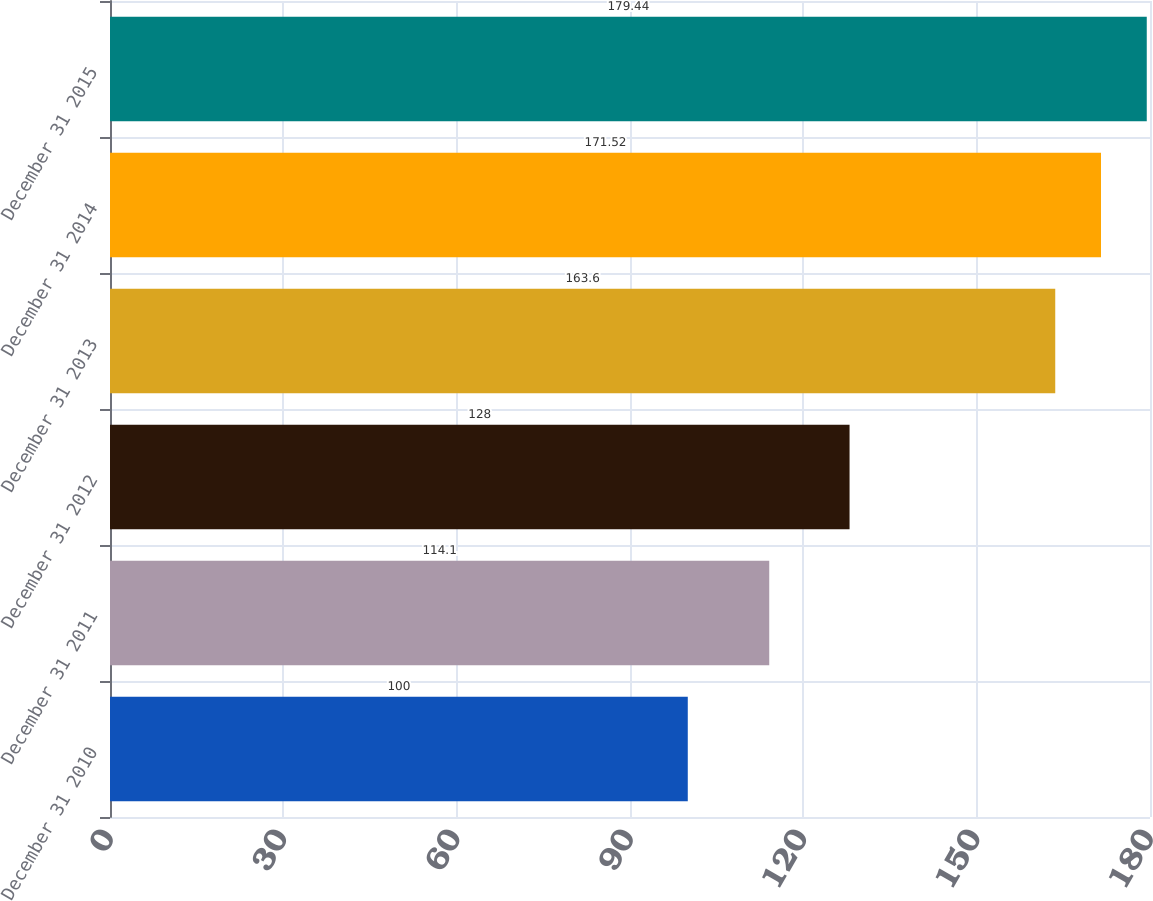Convert chart. <chart><loc_0><loc_0><loc_500><loc_500><bar_chart><fcel>December 31 2010<fcel>December 31 2011<fcel>December 31 2012<fcel>December 31 2013<fcel>December 31 2014<fcel>December 31 2015<nl><fcel>100<fcel>114.1<fcel>128<fcel>163.6<fcel>171.52<fcel>179.44<nl></chart> 